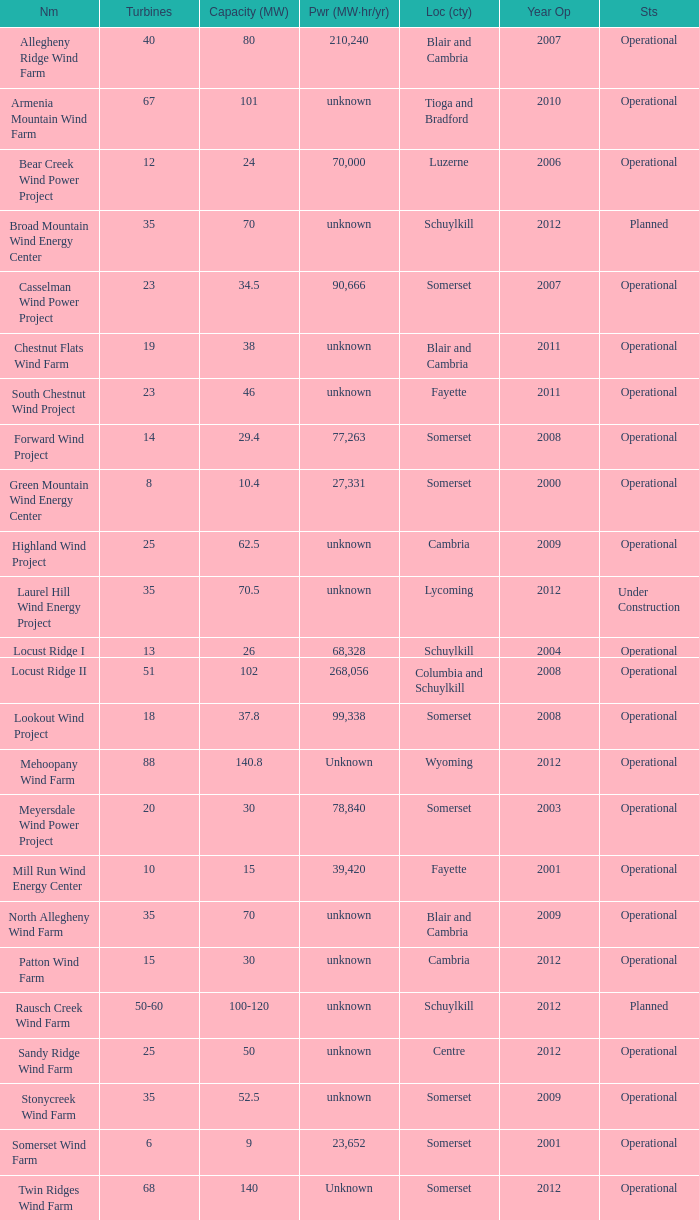What all capacities have turbines between 50-60? 100-120. 